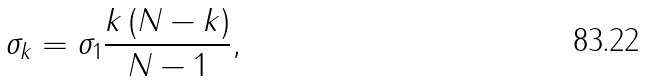Convert formula to latex. <formula><loc_0><loc_0><loc_500><loc_500>\sigma _ { k } = \sigma _ { 1 } \frac { k \left ( N - k \right ) } { N - 1 } ,</formula> 